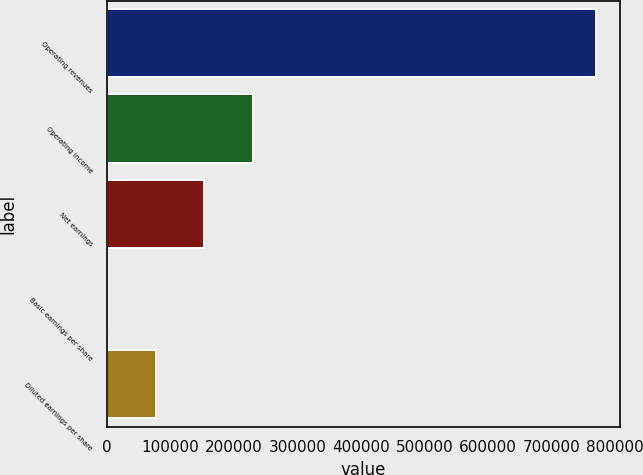<chart> <loc_0><loc_0><loc_500><loc_500><bar_chart><fcel>Operating revenues<fcel>Operating income<fcel>Net earnings<fcel>Basic earnings per share<fcel>Diluted earnings per share<nl><fcel>769784<fcel>230935<fcel>153957<fcel>0.19<fcel>76978.6<nl></chart> 